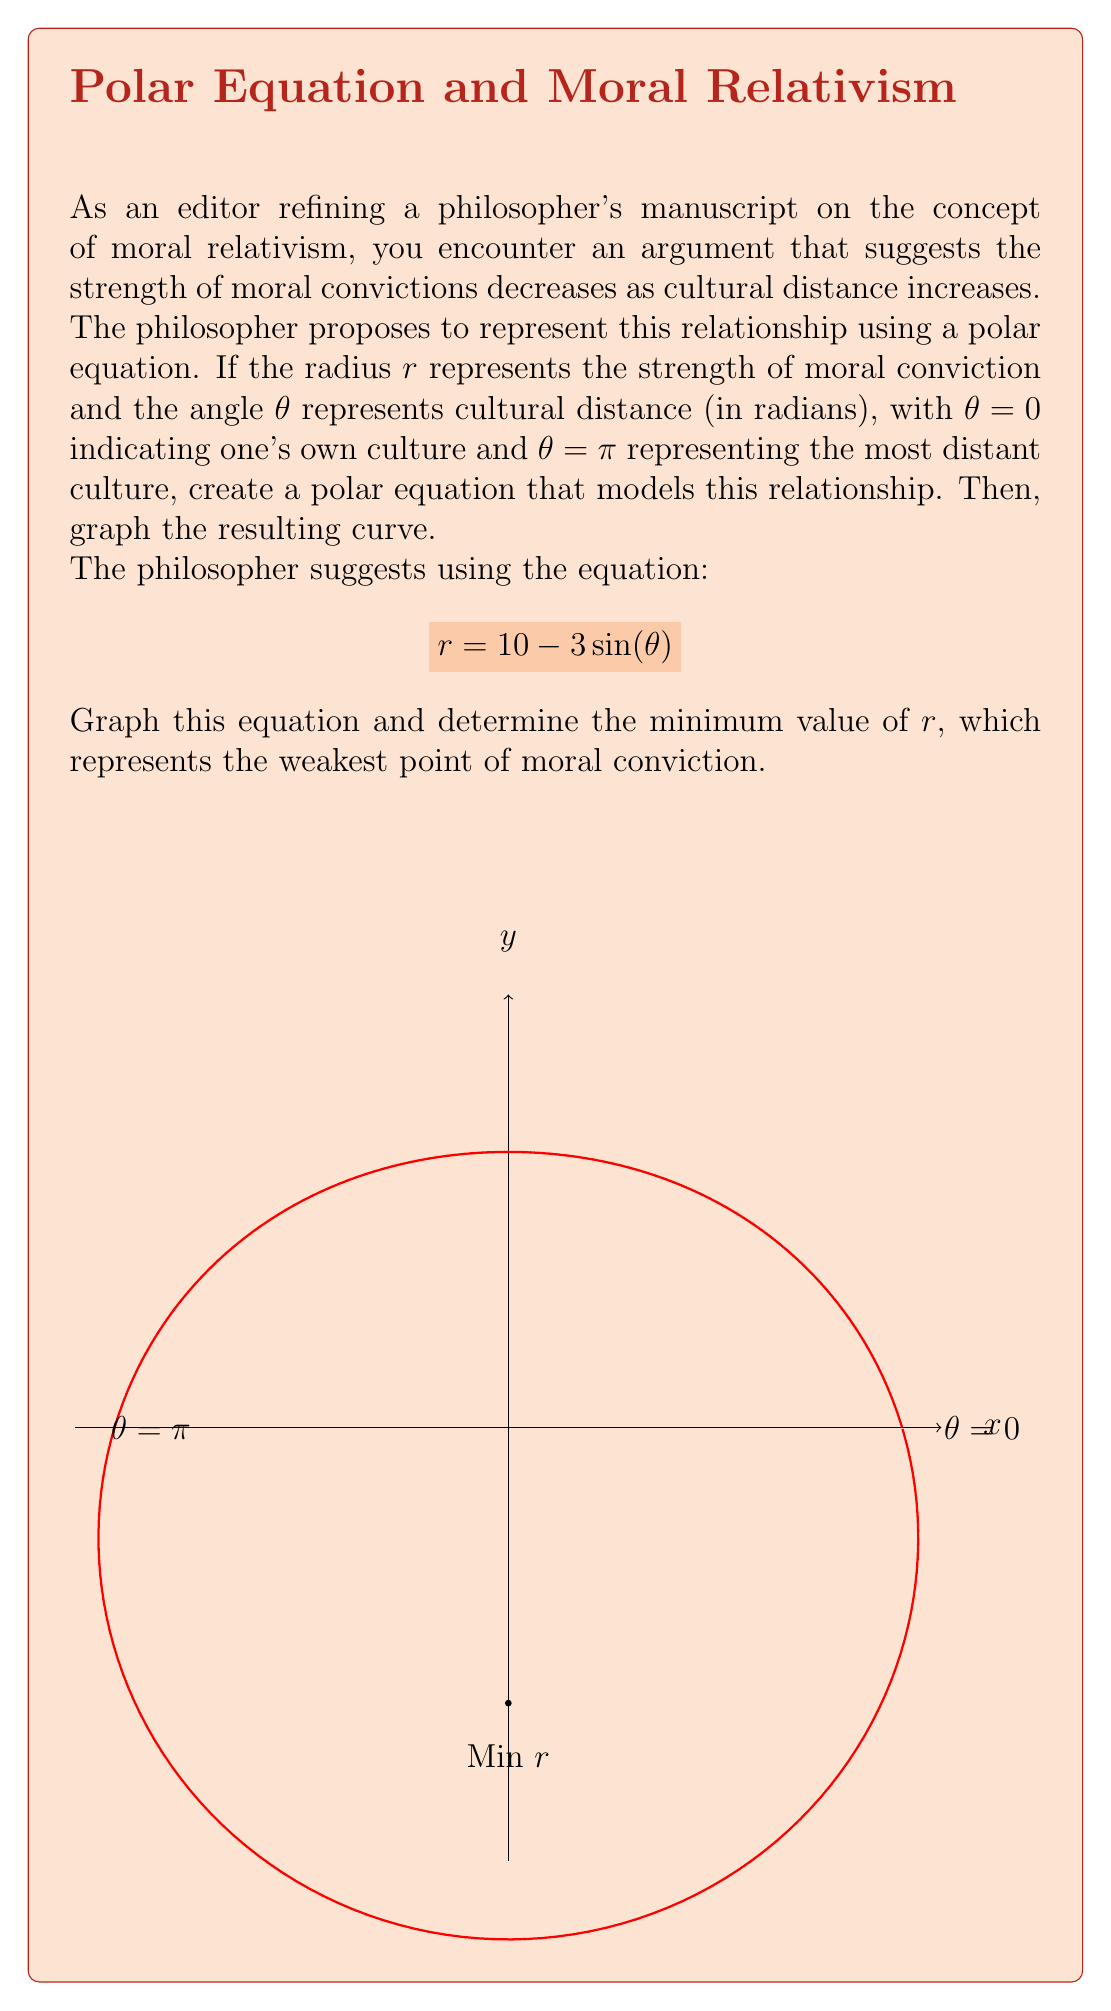Teach me how to tackle this problem. To solve this problem, we'll follow these steps:

1) First, let's understand the given polar equation:
   $$r = 10 - 3\sin(\theta)$$
   This equation represents a limaçon, a special type of polar curve.

2) To find the minimum value of $r$, we need to find where $\sin(\theta)$ is at its maximum, as this will make $r$ smallest.

3) We know that $\sin(\theta)$ reaches its maximum value of 1 when $\theta = \frac{\pi}{2}$ (90 degrees).

4) Let's calculate the minimum value of $r$:
   $$r_{min} = 10 - 3\sin(\frac{\pi}{2}) = 10 - 3(1) = 7$$

5) This minimum occurs at $\theta = \frac{\pi}{2}$, which in the context of the philosophical argument, represents a culture at a "middle distance" from one's own.

6) The graph shows this curve. The minimum point is at $(0, -7)$ in Cartesian coordinates, which corresponds to $r = 7$ and $\theta = \frac{\pi}{2}$ in polar coordinates.

7) Interpreting this philosophically: moral convictions are strongest in one's own culture ($\theta = 0$, $r = 10$), weakest at a middle cultural distance ($\theta = \frac{\pi}{2}$, $r = 7$), and then strengthen again for the most distant cultures ($\theta = \pi$, $r = 10$), possibly due to increased objectivity at greater cultural distances.
Answer: $r_{min} = 7$ at $\theta = \frac{\pi}{2}$ 